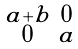<formula> <loc_0><loc_0><loc_500><loc_500>\begin{smallmatrix} a + b & 0 \\ 0 & a \end{smallmatrix}</formula> 